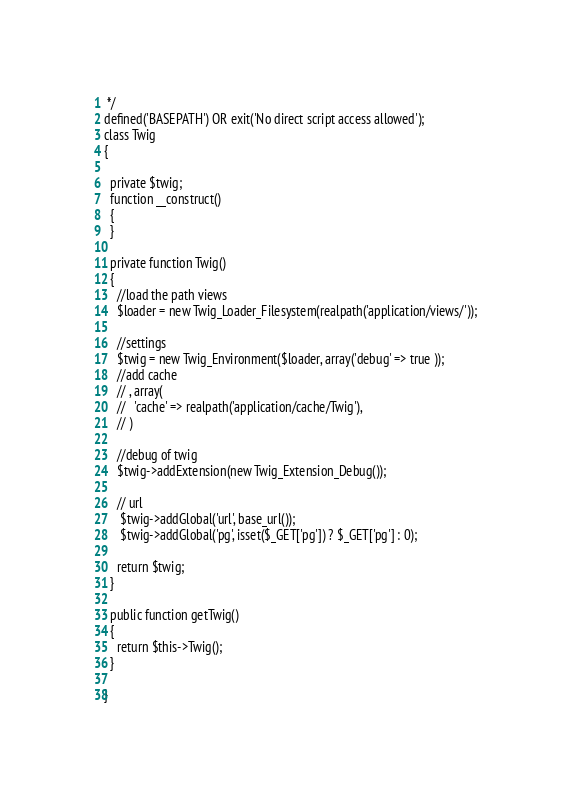<code> <loc_0><loc_0><loc_500><loc_500><_PHP_> */
defined('BASEPATH') OR exit('No direct script access allowed');
class Twig
{

  private $twig;
  function __construct()
  {
  }

  private function Twig()
  {
    //load the path views
    $loader = new Twig_Loader_Filesystem(realpath('application/views/'));

    //settings
    $twig = new Twig_Environment($loader, array('debug' => true ));
    //add cache
    // , array(
    //   'cache' => realpath('application/cache/Twig'),
    // )

    //debug of twig
    $twig->addExtension(new Twig_Extension_Debug());

    // url
     $twig->addGlobal('url', base_url());
     $twig->addGlobal('pg', isset($_GET['pg']) ? $_GET['pg'] : 0);

    return $twig;
  }

  public function getTwig()
  {
    return $this->Twig();
  }

}
</code> 